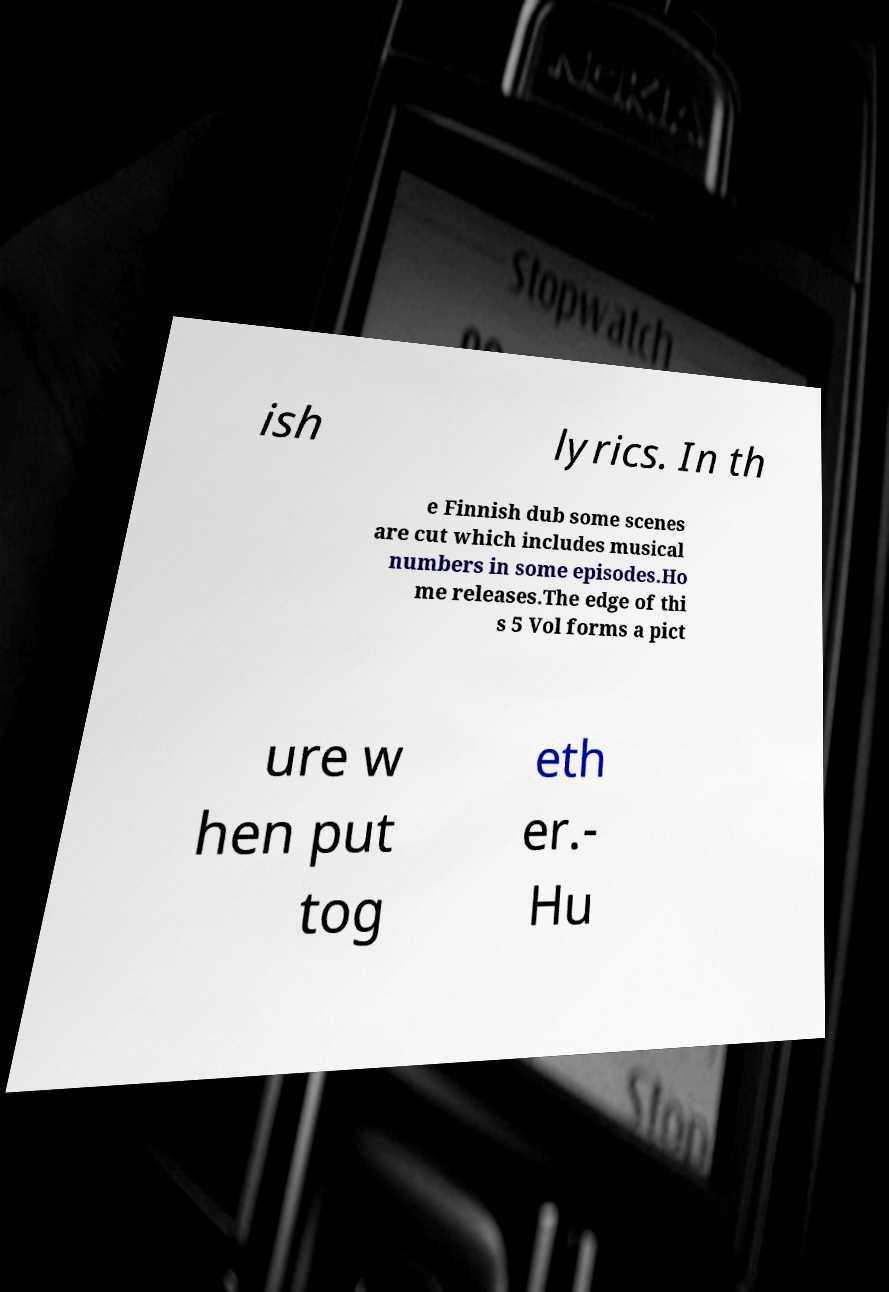Can you accurately transcribe the text from the provided image for me? ish lyrics. In th e Finnish dub some scenes are cut which includes musical numbers in some episodes.Ho me releases.The edge of thi s 5 Vol forms a pict ure w hen put tog eth er.- Hu 